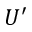<formula> <loc_0><loc_0><loc_500><loc_500>U ^ { \prime }</formula> 